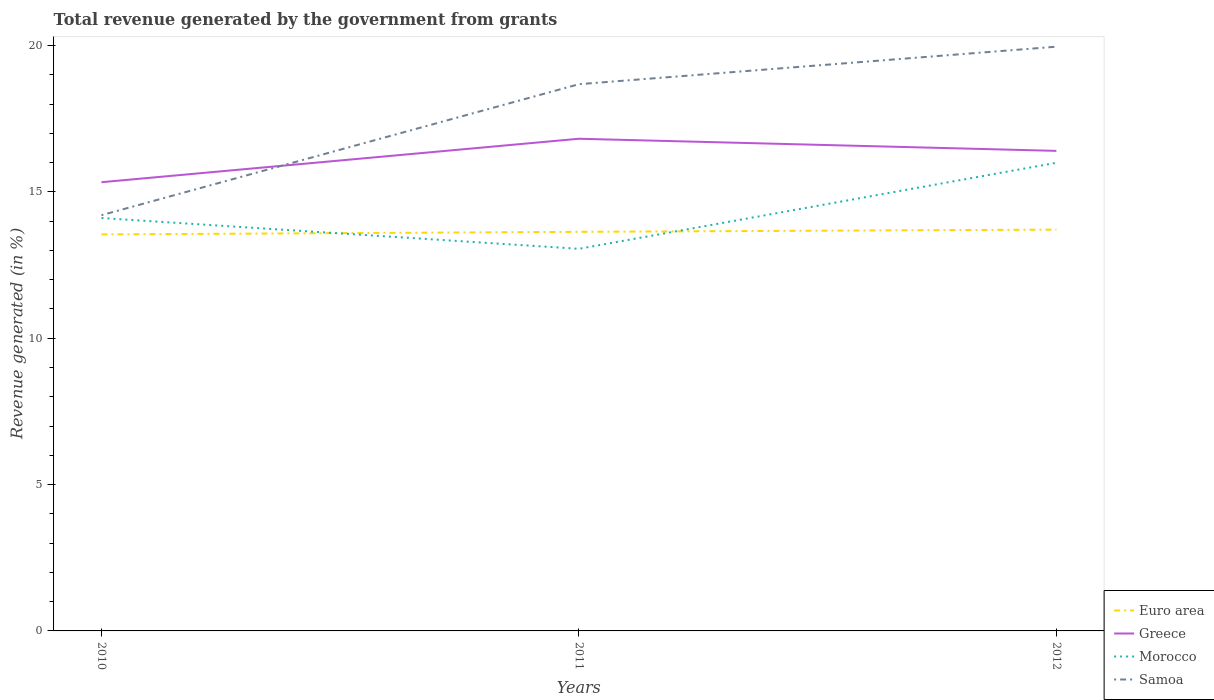How many different coloured lines are there?
Provide a succinct answer. 4. Is the number of lines equal to the number of legend labels?
Provide a short and direct response. Yes. Across all years, what is the maximum total revenue generated in Euro area?
Ensure brevity in your answer.  13.55. In which year was the total revenue generated in Morocco maximum?
Provide a short and direct response. 2011. What is the total total revenue generated in Morocco in the graph?
Offer a very short reply. 1.05. What is the difference between the highest and the second highest total revenue generated in Morocco?
Provide a short and direct response. 2.94. What is the difference between the highest and the lowest total revenue generated in Euro area?
Ensure brevity in your answer.  2. How many years are there in the graph?
Give a very brief answer. 3. Does the graph contain grids?
Make the answer very short. No. What is the title of the graph?
Provide a succinct answer. Total revenue generated by the government from grants. Does "China" appear as one of the legend labels in the graph?
Offer a very short reply. No. What is the label or title of the Y-axis?
Give a very brief answer. Revenue generated (in %). What is the Revenue generated (in %) of Euro area in 2010?
Your response must be concise. 13.55. What is the Revenue generated (in %) of Greece in 2010?
Your response must be concise. 15.33. What is the Revenue generated (in %) of Morocco in 2010?
Ensure brevity in your answer.  14.11. What is the Revenue generated (in %) in Samoa in 2010?
Ensure brevity in your answer.  14.2. What is the Revenue generated (in %) in Euro area in 2011?
Make the answer very short. 13.63. What is the Revenue generated (in %) in Greece in 2011?
Provide a short and direct response. 16.81. What is the Revenue generated (in %) of Morocco in 2011?
Provide a succinct answer. 13.05. What is the Revenue generated (in %) in Samoa in 2011?
Offer a terse response. 18.68. What is the Revenue generated (in %) of Euro area in 2012?
Make the answer very short. 13.71. What is the Revenue generated (in %) in Greece in 2012?
Your answer should be very brief. 16.4. What is the Revenue generated (in %) of Morocco in 2012?
Offer a terse response. 15.99. What is the Revenue generated (in %) of Samoa in 2012?
Offer a terse response. 19.96. Across all years, what is the maximum Revenue generated (in %) in Euro area?
Your response must be concise. 13.71. Across all years, what is the maximum Revenue generated (in %) of Greece?
Your response must be concise. 16.81. Across all years, what is the maximum Revenue generated (in %) in Morocco?
Offer a terse response. 15.99. Across all years, what is the maximum Revenue generated (in %) of Samoa?
Your response must be concise. 19.96. Across all years, what is the minimum Revenue generated (in %) in Euro area?
Offer a very short reply. 13.55. Across all years, what is the minimum Revenue generated (in %) in Greece?
Your response must be concise. 15.33. Across all years, what is the minimum Revenue generated (in %) in Morocco?
Give a very brief answer. 13.05. Across all years, what is the minimum Revenue generated (in %) in Samoa?
Give a very brief answer. 14.2. What is the total Revenue generated (in %) in Euro area in the graph?
Your response must be concise. 40.89. What is the total Revenue generated (in %) of Greece in the graph?
Your answer should be very brief. 48.55. What is the total Revenue generated (in %) of Morocco in the graph?
Your answer should be compact. 43.16. What is the total Revenue generated (in %) in Samoa in the graph?
Provide a succinct answer. 52.84. What is the difference between the Revenue generated (in %) of Euro area in 2010 and that in 2011?
Keep it short and to the point. -0.09. What is the difference between the Revenue generated (in %) of Greece in 2010 and that in 2011?
Ensure brevity in your answer.  -1.48. What is the difference between the Revenue generated (in %) in Morocco in 2010 and that in 2011?
Your answer should be very brief. 1.05. What is the difference between the Revenue generated (in %) of Samoa in 2010 and that in 2011?
Give a very brief answer. -4.47. What is the difference between the Revenue generated (in %) of Euro area in 2010 and that in 2012?
Provide a succinct answer. -0.16. What is the difference between the Revenue generated (in %) of Greece in 2010 and that in 2012?
Provide a succinct answer. -1.07. What is the difference between the Revenue generated (in %) in Morocco in 2010 and that in 2012?
Your answer should be very brief. -1.89. What is the difference between the Revenue generated (in %) of Samoa in 2010 and that in 2012?
Keep it short and to the point. -5.76. What is the difference between the Revenue generated (in %) in Euro area in 2011 and that in 2012?
Provide a succinct answer. -0.08. What is the difference between the Revenue generated (in %) in Greece in 2011 and that in 2012?
Your response must be concise. 0.41. What is the difference between the Revenue generated (in %) in Morocco in 2011 and that in 2012?
Keep it short and to the point. -2.94. What is the difference between the Revenue generated (in %) in Samoa in 2011 and that in 2012?
Provide a succinct answer. -1.28. What is the difference between the Revenue generated (in %) in Euro area in 2010 and the Revenue generated (in %) in Greece in 2011?
Make the answer very short. -3.27. What is the difference between the Revenue generated (in %) of Euro area in 2010 and the Revenue generated (in %) of Morocco in 2011?
Offer a terse response. 0.49. What is the difference between the Revenue generated (in %) of Euro area in 2010 and the Revenue generated (in %) of Samoa in 2011?
Keep it short and to the point. -5.13. What is the difference between the Revenue generated (in %) in Greece in 2010 and the Revenue generated (in %) in Morocco in 2011?
Offer a terse response. 2.28. What is the difference between the Revenue generated (in %) of Greece in 2010 and the Revenue generated (in %) of Samoa in 2011?
Provide a short and direct response. -3.35. What is the difference between the Revenue generated (in %) in Morocco in 2010 and the Revenue generated (in %) in Samoa in 2011?
Provide a succinct answer. -4.57. What is the difference between the Revenue generated (in %) in Euro area in 2010 and the Revenue generated (in %) in Greece in 2012?
Offer a very short reply. -2.85. What is the difference between the Revenue generated (in %) of Euro area in 2010 and the Revenue generated (in %) of Morocco in 2012?
Your answer should be compact. -2.45. What is the difference between the Revenue generated (in %) in Euro area in 2010 and the Revenue generated (in %) in Samoa in 2012?
Your answer should be very brief. -6.41. What is the difference between the Revenue generated (in %) in Greece in 2010 and the Revenue generated (in %) in Morocco in 2012?
Ensure brevity in your answer.  -0.66. What is the difference between the Revenue generated (in %) in Greece in 2010 and the Revenue generated (in %) in Samoa in 2012?
Your answer should be very brief. -4.63. What is the difference between the Revenue generated (in %) of Morocco in 2010 and the Revenue generated (in %) of Samoa in 2012?
Ensure brevity in your answer.  -5.85. What is the difference between the Revenue generated (in %) of Euro area in 2011 and the Revenue generated (in %) of Greece in 2012?
Offer a terse response. -2.77. What is the difference between the Revenue generated (in %) in Euro area in 2011 and the Revenue generated (in %) in Morocco in 2012?
Your response must be concise. -2.36. What is the difference between the Revenue generated (in %) of Euro area in 2011 and the Revenue generated (in %) of Samoa in 2012?
Ensure brevity in your answer.  -6.33. What is the difference between the Revenue generated (in %) in Greece in 2011 and the Revenue generated (in %) in Morocco in 2012?
Give a very brief answer. 0.82. What is the difference between the Revenue generated (in %) of Greece in 2011 and the Revenue generated (in %) of Samoa in 2012?
Provide a short and direct response. -3.15. What is the difference between the Revenue generated (in %) in Morocco in 2011 and the Revenue generated (in %) in Samoa in 2012?
Your answer should be very brief. -6.91. What is the average Revenue generated (in %) in Euro area per year?
Your response must be concise. 13.63. What is the average Revenue generated (in %) of Greece per year?
Your answer should be very brief. 16.18. What is the average Revenue generated (in %) in Morocco per year?
Give a very brief answer. 14.38. What is the average Revenue generated (in %) in Samoa per year?
Keep it short and to the point. 17.61. In the year 2010, what is the difference between the Revenue generated (in %) in Euro area and Revenue generated (in %) in Greece?
Provide a short and direct response. -1.78. In the year 2010, what is the difference between the Revenue generated (in %) in Euro area and Revenue generated (in %) in Morocco?
Offer a very short reply. -0.56. In the year 2010, what is the difference between the Revenue generated (in %) of Euro area and Revenue generated (in %) of Samoa?
Offer a terse response. -0.66. In the year 2010, what is the difference between the Revenue generated (in %) of Greece and Revenue generated (in %) of Morocco?
Make the answer very short. 1.22. In the year 2010, what is the difference between the Revenue generated (in %) in Greece and Revenue generated (in %) in Samoa?
Your response must be concise. 1.13. In the year 2010, what is the difference between the Revenue generated (in %) of Morocco and Revenue generated (in %) of Samoa?
Offer a terse response. -0.1. In the year 2011, what is the difference between the Revenue generated (in %) in Euro area and Revenue generated (in %) in Greece?
Make the answer very short. -3.18. In the year 2011, what is the difference between the Revenue generated (in %) in Euro area and Revenue generated (in %) in Morocco?
Your response must be concise. 0.58. In the year 2011, what is the difference between the Revenue generated (in %) of Euro area and Revenue generated (in %) of Samoa?
Your answer should be compact. -5.04. In the year 2011, what is the difference between the Revenue generated (in %) of Greece and Revenue generated (in %) of Morocco?
Provide a short and direct response. 3.76. In the year 2011, what is the difference between the Revenue generated (in %) in Greece and Revenue generated (in %) in Samoa?
Ensure brevity in your answer.  -1.86. In the year 2011, what is the difference between the Revenue generated (in %) in Morocco and Revenue generated (in %) in Samoa?
Make the answer very short. -5.62. In the year 2012, what is the difference between the Revenue generated (in %) of Euro area and Revenue generated (in %) of Greece?
Your answer should be compact. -2.69. In the year 2012, what is the difference between the Revenue generated (in %) in Euro area and Revenue generated (in %) in Morocco?
Make the answer very short. -2.28. In the year 2012, what is the difference between the Revenue generated (in %) in Euro area and Revenue generated (in %) in Samoa?
Offer a very short reply. -6.25. In the year 2012, what is the difference between the Revenue generated (in %) in Greece and Revenue generated (in %) in Morocco?
Offer a very short reply. 0.41. In the year 2012, what is the difference between the Revenue generated (in %) of Greece and Revenue generated (in %) of Samoa?
Your response must be concise. -3.56. In the year 2012, what is the difference between the Revenue generated (in %) in Morocco and Revenue generated (in %) in Samoa?
Keep it short and to the point. -3.97. What is the ratio of the Revenue generated (in %) of Euro area in 2010 to that in 2011?
Your answer should be very brief. 0.99. What is the ratio of the Revenue generated (in %) in Greece in 2010 to that in 2011?
Make the answer very short. 0.91. What is the ratio of the Revenue generated (in %) in Morocco in 2010 to that in 2011?
Offer a very short reply. 1.08. What is the ratio of the Revenue generated (in %) of Samoa in 2010 to that in 2011?
Make the answer very short. 0.76. What is the ratio of the Revenue generated (in %) of Greece in 2010 to that in 2012?
Make the answer very short. 0.93. What is the ratio of the Revenue generated (in %) of Morocco in 2010 to that in 2012?
Give a very brief answer. 0.88. What is the ratio of the Revenue generated (in %) in Samoa in 2010 to that in 2012?
Offer a very short reply. 0.71. What is the ratio of the Revenue generated (in %) in Euro area in 2011 to that in 2012?
Your answer should be very brief. 0.99. What is the ratio of the Revenue generated (in %) in Greece in 2011 to that in 2012?
Your response must be concise. 1.03. What is the ratio of the Revenue generated (in %) of Morocco in 2011 to that in 2012?
Your response must be concise. 0.82. What is the ratio of the Revenue generated (in %) of Samoa in 2011 to that in 2012?
Ensure brevity in your answer.  0.94. What is the difference between the highest and the second highest Revenue generated (in %) of Euro area?
Make the answer very short. 0.08. What is the difference between the highest and the second highest Revenue generated (in %) in Greece?
Keep it short and to the point. 0.41. What is the difference between the highest and the second highest Revenue generated (in %) in Morocco?
Offer a terse response. 1.89. What is the difference between the highest and the second highest Revenue generated (in %) of Samoa?
Give a very brief answer. 1.28. What is the difference between the highest and the lowest Revenue generated (in %) in Euro area?
Offer a terse response. 0.16. What is the difference between the highest and the lowest Revenue generated (in %) of Greece?
Your response must be concise. 1.48. What is the difference between the highest and the lowest Revenue generated (in %) of Morocco?
Provide a succinct answer. 2.94. What is the difference between the highest and the lowest Revenue generated (in %) of Samoa?
Give a very brief answer. 5.76. 